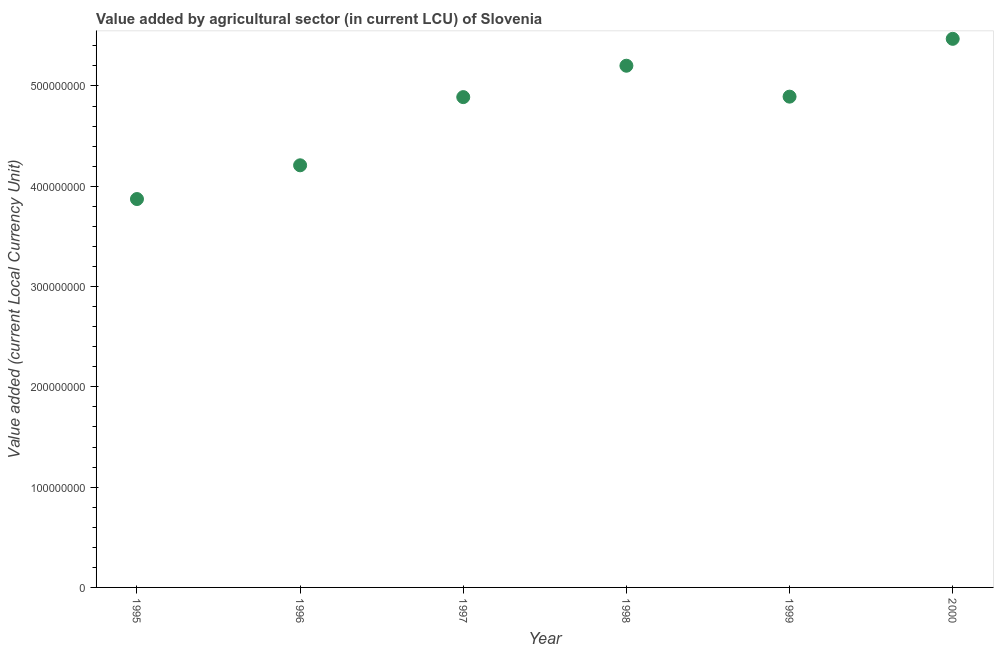What is the value added by agriculture sector in 2000?
Offer a terse response. 5.47e+08. Across all years, what is the maximum value added by agriculture sector?
Give a very brief answer. 5.47e+08. Across all years, what is the minimum value added by agriculture sector?
Offer a terse response. 3.87e+08. In which year was the value added by agriculture sector maximum?
Your answer should be compact. 2000. In which year was the value added by agriculture sector minimum?
Your answer should be compact. 1995. What is the sum of the value added by agriculture sector?
Make the answer very short. 2.85e+09. What is the difference between the value added by agriculture sector in 1995 and 1996?
Provide a short and direct response. -3.36e+07. What is the average value added by agriculture sector per year?
Your response must be concise. 4.76e+08. What is the median value added by agriculture sector?
Your answer should be very brief. 4.89e+08. In how many years, is the value added by agriculture sector greater than 260000000 LCU?
Offer a terse response. 6. Do a majority of the years between 1999 and 1998 (inclusive) have value added by agriculture sector greater than 260000000 LCU?
Make the answer very short. No. What is the ratio of the value added by agriculture sector in 1996 to that in 1997?
Keep it short and to the point. 0.86. Is the value added by agriculture sector in 1995 less than that in 2000?
Offer a terse response. Yes. Is the difference between the value added by agriculture sector in 1995 and 1997 greater than the difference between any two years?
Your answer should be compact. No. What is the difference between the highest and the second highest value added by agriculture sector?
Make the answer very short. 2.68e+07. Is the sum of the value added by agriculture sector in 1996 and 2000 greater than the maximum value added by agriculture sector across all years?
Make the answer very short. Yes. What is the difference between the highest and the lowest value added by agriculture sector?
Offer a very short reply. 1.60e+08. How many dotlines are there?
Keep it short and to the point. 1. How many years are there in the graph?
Provide a short and direct response. 6. Are the values on the major ticks of Y-axis written in scientific E-notation?
Provide a short and direct response. No. Does the graph contain any zero values?
Provide a short and direct response. No. Does the graph contain grids?
Offer a very short reply. No. What is the title of the graph?
Your answer should be very brief. Value added by agricultural sector (in current LCU) of Slovenia. What is the label or title of the Y-axis?
Give a very brief answer. Value added (current Local Currency Unit). What is the Value added (current Local Currency Unit) in 1995?
Provide a short and direct response. 3.87e+08. What is the Value added (current Local Currency Unit) in 1996?
Offer a very short reply. 4.21e+08. What is the Value added (current Local Currency Unit) in 1997?
Offer a very short reply. 4.89e+08. What is the Value added (current Local Currency Unit) in 1998?
Your answer should be very brief. 5.20e+08. What is the Value added (current Local Currency Unit) in 1999?
Give a very brief answer. 4.89e+08. What is the Value added (current Local Currency Unit) in 2000?
Give a very brief answer. 5.47e+08. What is the difference between the Value added (current Local Currency Unit) in 1995 and 1996?
Ensure brevity in your answer.  -3.36e+07. What is the difference between the Value added (current Local Currency Unit) in 1995 and 1997?
Your response must be concise. -1.02e+08. What is the difference between the Value added (current Local Currency Unit) in 1995 and 1998?
Your answer should be compact. -1.33e+08. What is the difference between the Value added (current Local Currency Unit) in 1995 and 1999?
Your answer should be very brief. -1.02e+08. What is the difference between the Value added (current Local Currency Unit) in 1995 and 2000?
Your response must be concise. -1.60e+08. What is the difference between the Value added (current Local Currency Unit) in 1996 and 1997?
Your answer should be very brief. -6.80e+07. What is the difference between the Value added (current Local Currency Unit) in 1996 and 1998?
Your response must be concise. -9.93e+07. What is the difference between the Value added (current Local Currency Unit) in 1996 and 1999?
Your answer should be very brief. -6.85e+07. What is the difference between the Value added (current Local Currency Unit) in 1996 and 2000?
Provide a short and direct response. -1.26e+08. What is the difference between the Value added (current Local Currency Unit) in 1997 and 1998?
Your answer should be compact. -3.13e+07. What is the difference between the Value added (current Local Currency Unit) in 1997 and 1999?
Your answer should be compact. -4.70e+05. What is the difference between the Value added (current Local Currency Unit) in 1997 and 2000?
Your answer should be compact. -5.81e+07. What is the difference between the Value added (current Local Currency Unit) in 1998 and 1999?
Offer a terse response. 3.08e+07. What is the difference between the Value added (current Local Currency Unit) in 1998 and 2000?
Keep it short and to the point. -2.68e+07. What is the difference between the Value added (current Local Currency Unit) in 1999 and 2000?
Keep it short and to the point. -5.76e+07. What is the ratio of the Value added (current Local Currency Unit) in 1995 to that in 1997?
Offer a terse response. 0.79. What is the ratio of the Value added (current Local Currency Unit) in 1995 to that in 1998?
Give a very brief answer. 0.74. What is the ratio of the Value added (current Local Currency Unit) in 1995 to that in 1999?
Make the answer very short. 0.79. What is the ratio of the Value added (current Local Currency Unit) in 1995 to that in 2000?
Make the answer very short. 0.71. What is the ratio of the Value added (current Local Currency Unit) in 1996 to that in 1997?
Provide a succinct answer. 0.86. What is the ratio of the Value added (current Local Currency Unit) in 1996 to that in 1998?
Offer a terse response. 0.81. What is the ratio of the Value added (current Local Currency Unit) in 1996 to that in 1999?
Your answer should be compact. 0.86. What is the ratio of the Value added (current Local Currency Unit) in 1996 to that in 2000?
Your answer should be very brief. 0.77. What is the ratio of the Value added (current Local Currency Unit) in 1997 to that in 1999?
Your response must be concise. 1. What is the ratio of the Value added (current Local Currency Unit) in 1997 to that in 2000?
Offer a very short reply. 0.89. What is the ratio of the Value added (current Local Currency Unit) in 1998 to that in 1999?
Keep it short and to the point. 1.06. What is the ratio of the Value added (current Local Currency Unit) in 1998 to that in 2000?
Your answer should be compact. 0.95. What is the ratio of the Value added (current Local Currency Unit) in 1999 to that in 2000?
Provide a succinct answer. 0.9. 